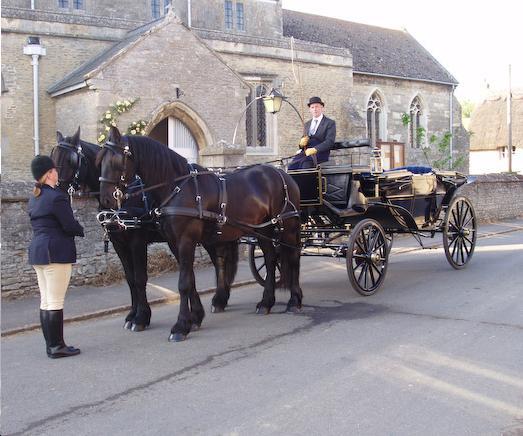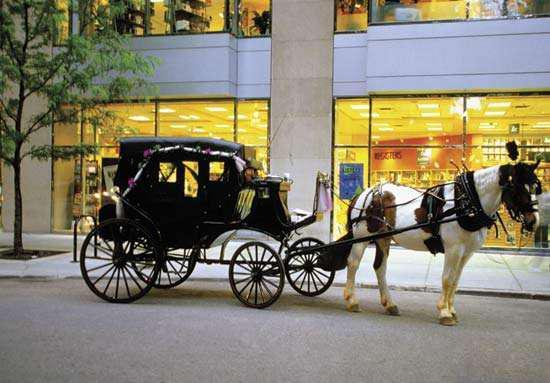The first image is the image on the left, the second image is the image on the right. For the images displayed, is the sentence "Five or fewer mammals are visible." factually correct? Answer yes or no. Yes. The first image is the image on the left, the second image is the image on the right. Given the left and right images, does the statement "The left image shows a carriage but no horses." hold true? Answer yes or no. No. 